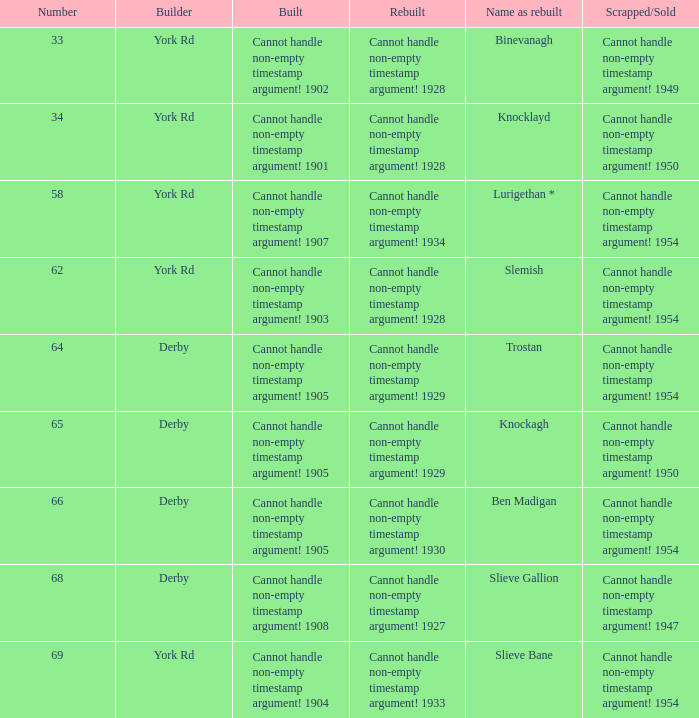Which discarded or sold item has the name "rebuilt of trostan"? Cannot handle non-empty timestamp argument! 1954. 